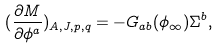<formula> <loc_0><loc_0><loc_500><loc_500>( \frac { \partial M } { \partial \phi ^ { a } } ) _ { A , J , p , q } = - G _ { a b } ( \phi _ { \infty } ) \Sigma ^ { b } ,</formula> 